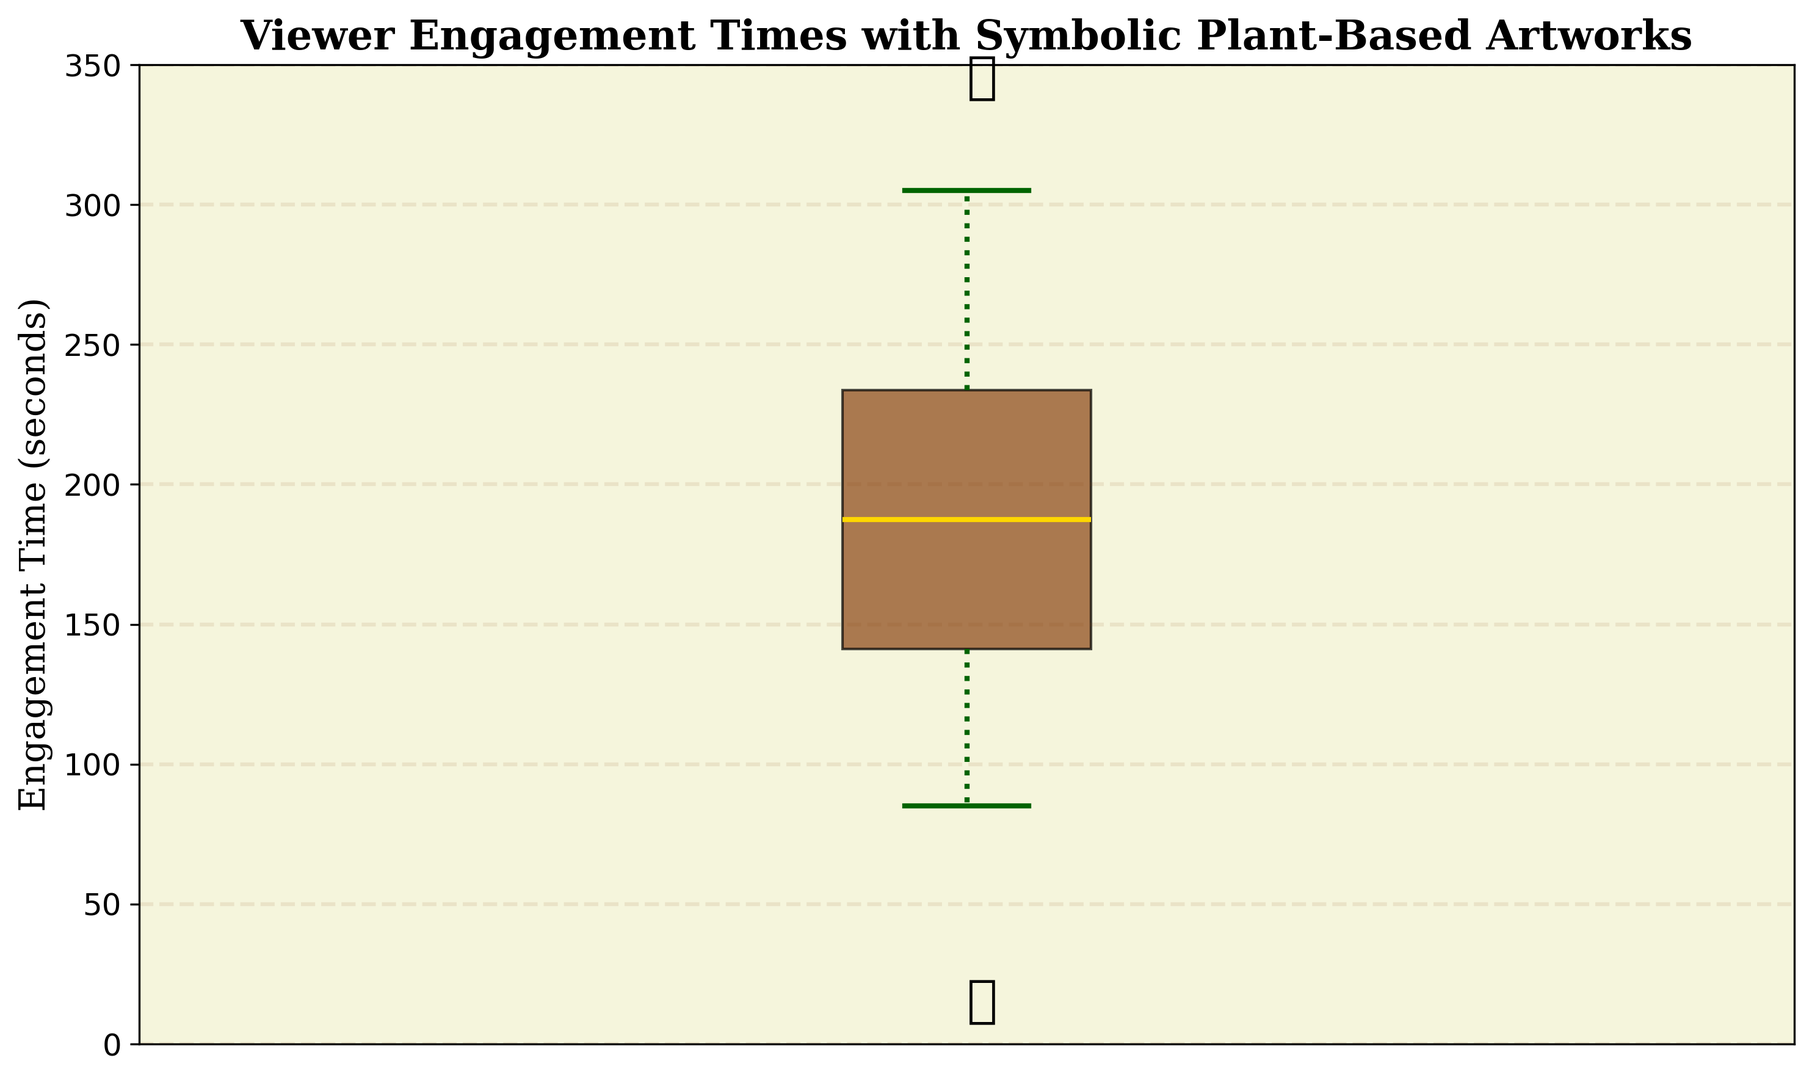What's the median engagement time of viewers? The median is the middle value when the data points are ordered. Since there are 30 data points, the median will be the average of the 15th and 16th values in the ordered list. 170 (15th) + 175 (16th) = 345, then 345 / 2 = 172.5
Answer: 172.5 What's the interquartile range (IQR) for the engagement times? The IQR is the difference between the 75th percentile (Q3) and the 25th percentile (Q1) values. From the box plot, Q1 is around 125 seconds and Q3 is around 240 seconds, so IQR = 240 - 125 = 115
Answer: 115 What is the lowest engagement time? The lowest value, or the minimum value, is the bottom whisker of the box plot. From the plot, the lowest engagement time is 85 seconds
Answer: 85 What is the highest engagement time? The highest value, or the maximum value, is the top whisker of the box plot. From the plot, the highest engagement time is 305 seconds
Answer: 305 Is there any outlier in engagement times? Outliers are data points that lie significantly outside the range of other points. From the plot, the presence of individual data points marked outside the whiskers indicates outliers. There are no such points shown here
Answer: No How does the median engagement time compare to the mean engagement time? To answer this, one would calculate the mean (sum of all engagement times divided by the number of viewers) and compare it with the median. Mean = (145 + 210 + 180 + 95 + 275 + 160 + 230 + 120 + 190 + 305 + 85 + 250 + 140 + 200 + 170 + 290 + 110 + 240 + 130 + 220 + 185 + 260 + 105 + 195 + 280 + 150 + 235 + 125 + 215 + 175) / 30 = 190, Median ≈ 172.5
Answer: Mean (190) is higher than Median (172.5) Between what values does the middle 50% of engagement times lie? The middle 50% of the data lies between the first quartile (Q1) and the third quartile (Q3). From the box plot, Q1 is about 125 seconds and Q3 is about 240 seconds
Answer: Between 125 and 240 seconds What is the range of the engagement times? The range is the difference between the maximum and minimum values. From the plot, Range = 305 - 85 = 220
Answer: 220 What color is used for the median line in the box plot? The median line is a distinct color indicating the central value of the dataset. It is shown in gold
Answer: Gold What is the color of the box in the box plot? The box, representing the interquartile range (IQR), is filled with a SaddleBrown color
Answer: SaddleBrown 